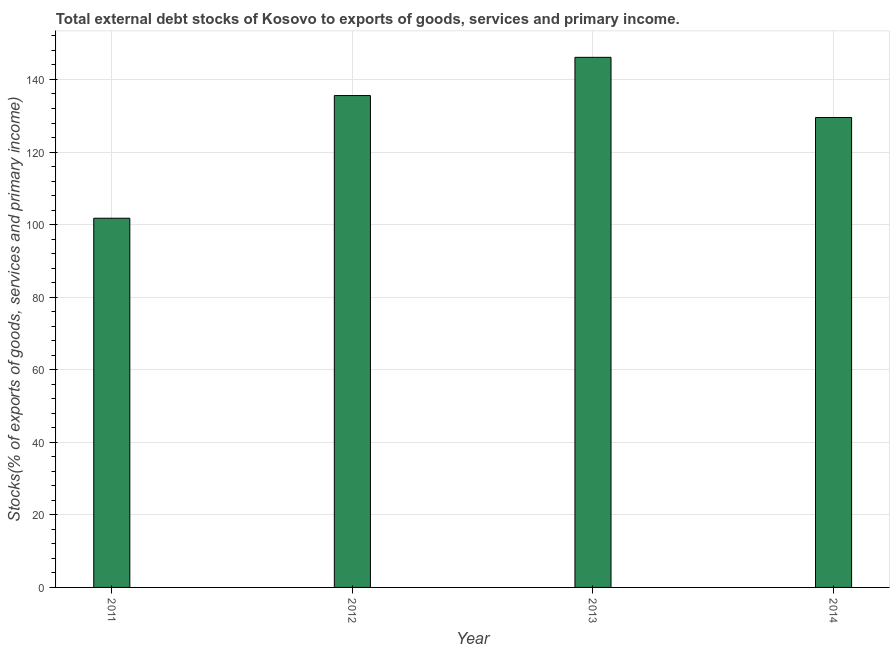Does the graph contain any zero values?
Offer a very short reply. No. Does the graph contain grids?
Give a very brief answer. Yes. What is the title of the graph?
Your answer should be compact. Total external debt stocks of Kosovo to exports of goods, services and primary income. What is the label or title of the Y-axis?
Keep it short and to the point. Stocks(% of exports of goods, services and primary income). What is the external debt stocks in 2014?
Make the answer very short. 129.52. Across all years, what is the maximum external debt stocks?
Make the answer very short. 146.11. Across all years, what is the minimum external debt stocks?
Give a very brief answer. 101.76. In which year was the external debt stocks maximum?
Offer a very short reply. 2013. In which year was the external debt stocks minimum?
Keep it short and to the point. 2011. What is the sum of the external debt stocks?
Give a very brief answer. 512.96. What is the difference between the external debt stocks in 2011 and 2014?
Offer a very short reply. -27.76. What is the average external debt stocks per year?
Your answer should be compact. 128.24. What is the median external debt stocks?
Provide a short and direct response. 132.55. Do a majority of the years between 2014 and 2011 (inclusive) have external debt stocks greater than 144 %?
Offer a terse response. Yes. What is the ratio of the external debt stocks in 2012 to that in 2014?
Your response must be concise. 1.05. What is the difference between the highest and the second highest external debt stocks?
Keep it short and to the point. 10.54. What is the difference between the highest and the lowest external debt stocks?
Keep it short and to the point. 44.35. In how many years, is the external debt stocks greater than the average external debt stocks taken over all years?
Make the answer very short. 3. How many bars are there?
Ensure brevity in your answer.  4. Are all the bars in the graph horizontal?
Provide a succinct answer. No. How many years are there in the graph?
Provide a short and direct response. 4. What is the Stocks(% of exports of goods, services and primary income) in 2011?
Provide a succinct answer. 101.76. What is the Stocks(% of exports of goods, services and primary income) in 2012?
Give a very brief answer. 135.57. What is the Stocks(% of exports of goods, services and primary income) in 2013?
Keep it short and to the point. 146.11. What is the Stocks(% of exports of goods, services and primary income) in 2014?
Give a very brief answer. 129.52. What is the difference between the Stocks(% of exports of goods, services and primary income) in 2011 and 2012?
Your answer should be very brief. -33.81. What is the difference between the Stocks(% of exports of goods, services and primary income) in 2011 and 2013?
Your answer should be very brief. -44.35. What is the difference between the Stocks(% of exports of goods, services and primary income) in 2011 and 2014?
Provide a succinct answer. -27.76. What is the difference between the Stocks(% of exports of goods, services and primary income) in 2012 and 2013?
Your answer should be compact. -10.54. What is the difference between the Stocks(% of exports of goods, services and primary income) in 2012 and 2014?
Give a very brief answer. 6.04. What is the difference between the Stocks(% of exports of goods, services and primary income) in 2013 and 2014?
Offer a very short reply. 16.58. What is the ratio of the Stocks(% of exports of goods, services and primary income) in 2011 to that in 2012?
Provide a short and direct response. 0.75. What is the ratio of the Stocks(% of exports of goods, services and primary income) in 2011 to that in 2013?
Your answer should be very brief. 0.7. What is the ratio of the Stocks(% of exports of goods, services and primary income) in 2011 to that in 2014?
Give a very brief answer. 0.79. What is the ratio of the Stocks(% of exports of goods, services and primary income) in 2012 to that in 2013?
Provide a short and direct response. 0.93. What is the ratio of the Stocks(% of exports of goods, services and primary income) in 2012 to that in 2014?
Give a very brief answer. 1.05. What is the ratio of the Stocks(% of exports of goods, services and primary income) in 2013 to that in 2014?
Your answer should be compact. 1.13. 